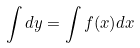Convert formula to latex. <formula><loc_0><loc_0><loc_500><loc_500>\int d y = \int f ( x ) d x</formula> 